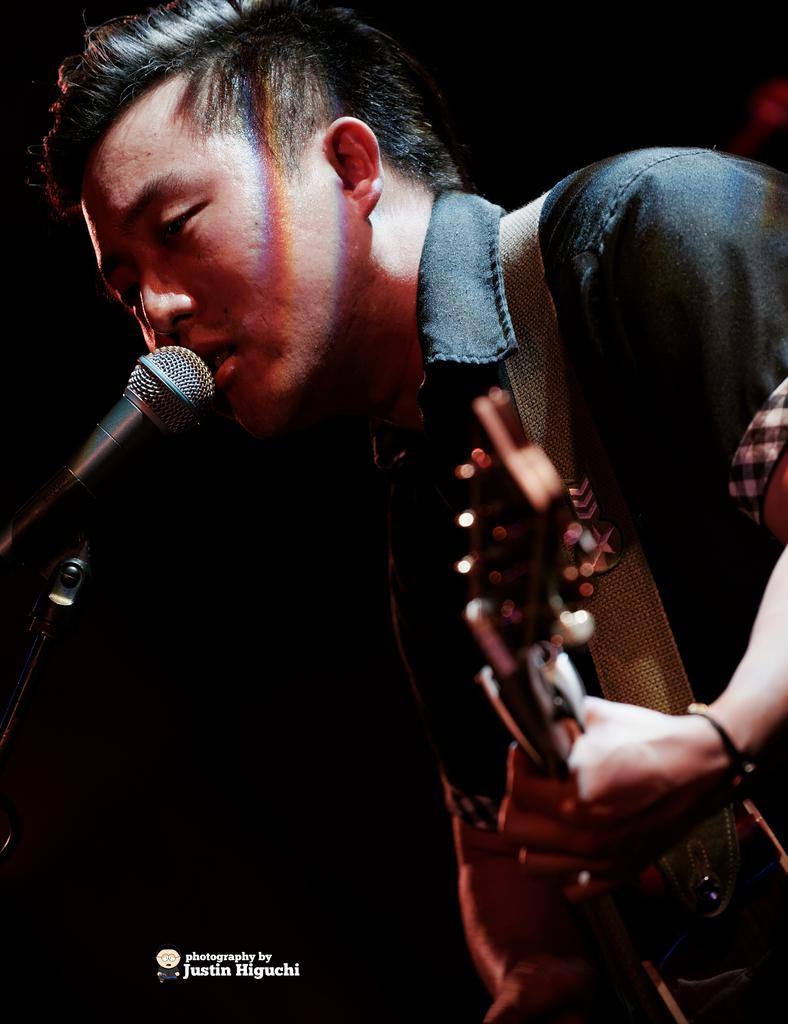Who is the main subject in the image? There is a man in the image. What is the man holding in the image? The man is holding a guitar. What is the man doing with the microphone in the image? The man is singing into a microphone. What can be observed about the lighting in the image? The background of the image appears to be dark. What type of rhythm can be heard in the background of the image? There is not something that can be heard or observed in the image; it is a visual medium. 